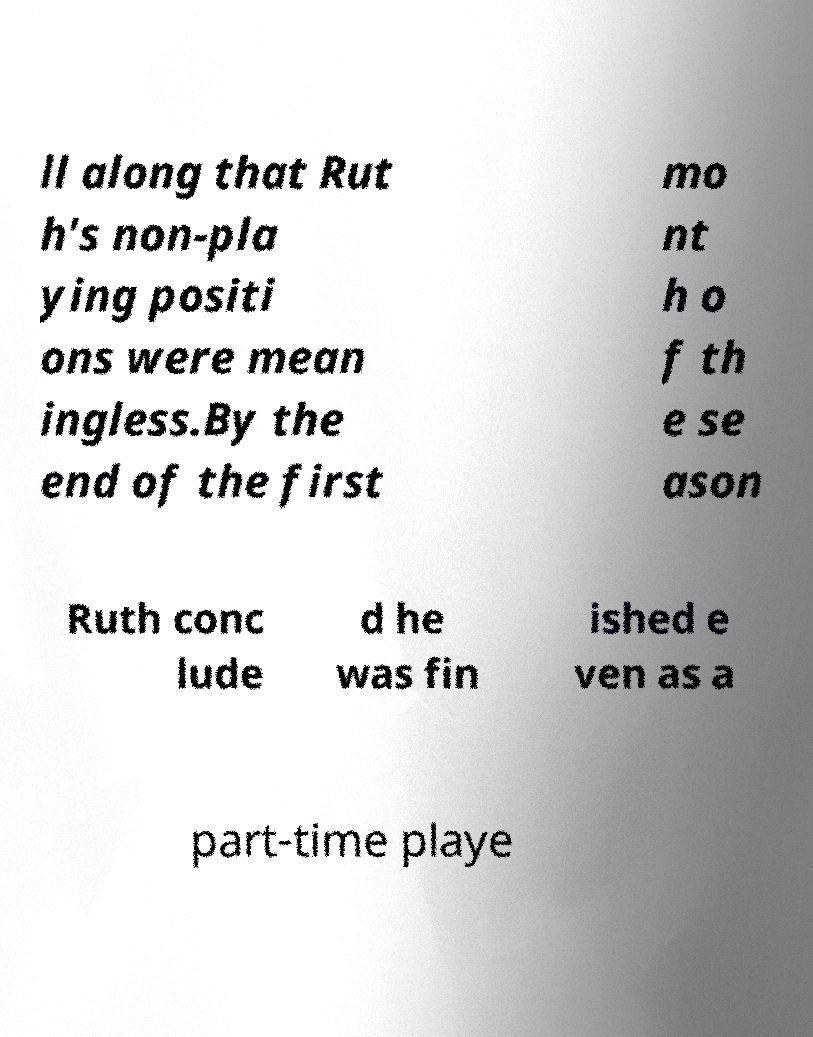There's text embedded in this image that I need extracted. Can you transcribe it verbatim? ll along that Rut h's non-pla ying positi ons were mean ingless.By the end of the first mo nt h o f th e se ason Ruth conc lude d he was fin ished e ven as a part-time playe 